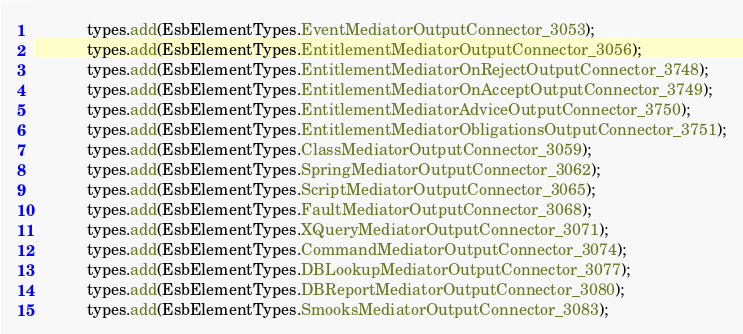<code> <loc_0><loc_0><loc_500><loc_500><_Java_>			types.add(EsbElementTypes.EventMediatorOutputConnector_3053);
			types.add(EsbElementTypes.EntitlementMediatorOutputConnector_3056);
			types.add(EsbElementTypes.EntitlementMediatorOnRejectOutputConnector_3748);
			types.add(EsbElementTypes.EntitlementMediatorOnAcceptOutputConnector_3749);
			types.add(EsbElementTypes.EntitlementMediatorAdviceOutputConnector_3750);
			types.add(EsbElementTypes.EntitlementMediatorObligationsOutputConnector_3751);
			types.add(EsbElementTypes.ClassMediatorOutputConnector_3059);
			types.add(EsbElementTypes.SpringMediatorOutputConnector_3062);
			types.add(EsbElementTypes.ScriptMediatorOutputConnector_3065);
			types.add(EsbElementTypes.FaultMediatorOutputConnector_3068);
			types.add(EsbElementTypes.XQueryMediatorOutputConnector_3071);
			types.add(EsbElementTypes.CommandMediatorOutputConnector_3074);
			types.add(EsbElementTypes.DBLookupMediatorOutputConnector_3077);
			types.add(EsbElementTypes.DBReportMediatorOutputConnector_3080);
			types.add(EsbElementTypes.SmooksMediatorOutputConnector_3083);</code> 